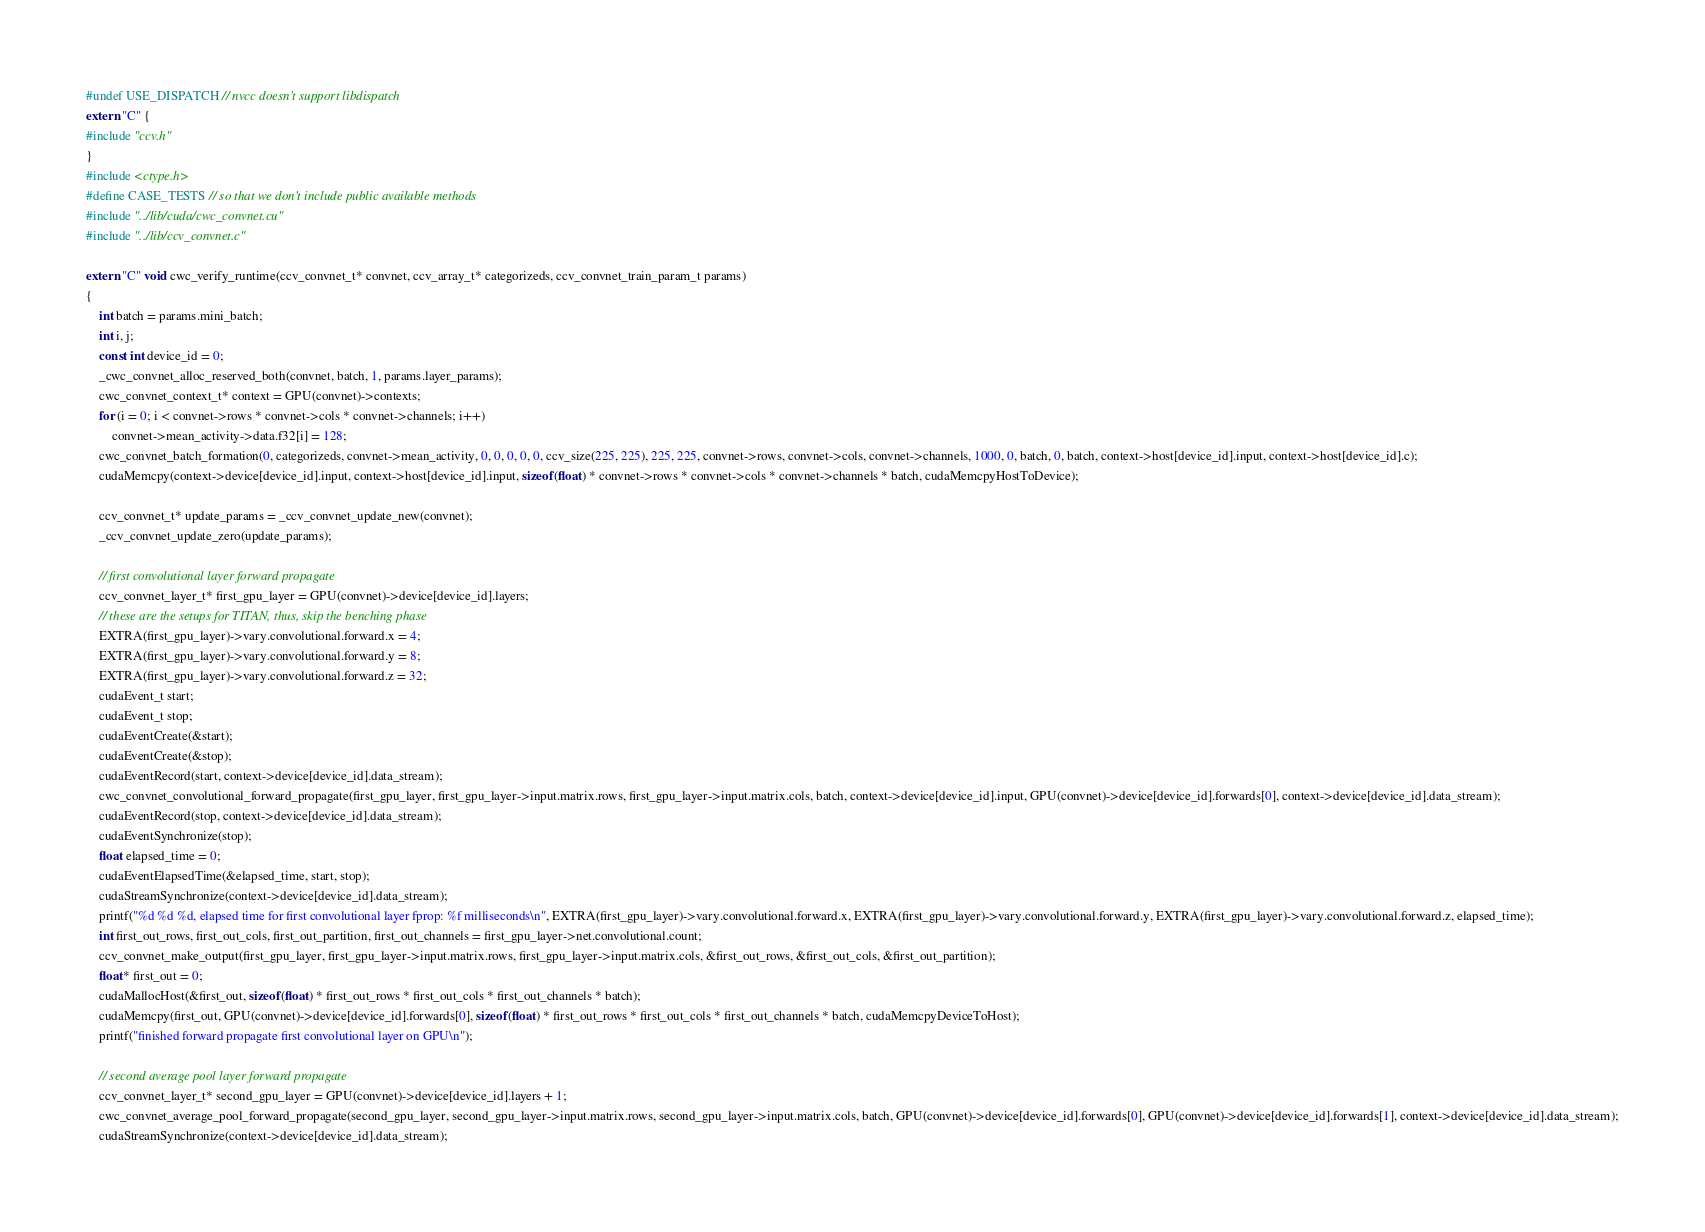<code> <loc_0><loc_0><loc_500><loc_500><_Cuda_>#undef USE_DISPATCH // nvcc doesn't support libdispatch
extern "C" {
#include "ccv.h"
}
#include <ctype.h>
#define CASE_TESTS // so that we don't include public available methods
#include "../lib/cuda/cwc_convnet.cu"
#include "../lib/ccv_convnet.c"

extern "C" void cwc_verify_runtime(ccv_convnet_t* convnet, ccv_array_t* categorizeds, ccv_convnet_train_param_t params)
{
	int batch = params.mini_batch;
	int i, j;
	const int device_id = 0;
	_cwc_convnet_alloc_reserved_both(convnet, batch, 1, params.layer_params);
	cwc_convnet_context_t* context = GPU(convnet)->contexts;
	for (i = 0; i < convnet->rows * convnet->cols * convnet->channels; i++)
		convnet->mean_activity->data.f32[i] = 128;
	cwc_convnet_batch_formation(0, categorizeds, convnet->mean_activity, 0, 0, 0, 0, 0, ccv_size(225, 225), 225, 225, convnet->rows, convnet->cols, convnet->channels, 1000, 0, batch, 0, batch, context->host[device_id].input, context->host[device_id].c);
	cudaMemcpy(context->device[device_id].input, context->host[device_id].input, sizeof(float) * convnet->rows * convnet->cols * convnet->channels * batch, cudaMemcpyHostToDevice);

	ccv_convnet_t* update_params = _ccv_convnet_update_new(convnet);
	_ccv_convnet_update_zero(update_params);

	// first convolutional layer forward propagate
	ccv_convnet_layer_t* first_gpu_layer = GPU(convnet)->device[device_id].layers;
	// these are the setups for TITAN, thus, skip the benching phase
	EXTRA(first_gpu_layer)->vary.convolutional.forward.x = 4;
	EXTRA(first_gpu_layer)->vary.convolutional.forward.y = 8;
	EXTRA(first_gpu_layer)->vary.convolutional.forward.z = 32;
	cudaEvent_t start;
	cudaEvent_t stop;
	cudaEventCreate(&start);
	cudaEventCreate(&stop);
	cudaEventRecord(start, context->device[device_id].data_stream);
	cwc_convnet_convolutional_forward_propagate(first_gpu_layer, first_gpu_layer->input.matrix.rows, first_gpu_layer->input.matrix.cols, batch, context->device[device_id].input, GPU(convnet)->device[device_id].forwards[0], context->device[device_id].data_stream);
	cudaEventRecord(stop, context->device[device_id].data_stream);
	cudaEventSynchronize(stop);
	float elapsed_time = 0;
	cudaEventElapsedTime(&elapsed_time, start, stop);
	cudaStreamSynchronize(context->device[device_id].data_stream);
	printf("%d %d %d, elapsed time for first convolutional layer fprop: %f milliseconds\n", EXTRA(first_gpu_layer)->vary.convolutional.forward.x, EXTRA(first_gpu_layer)->vary.convolutional.forward.y, EXTRA(first_gpu_layer)->vary.convolutional.forward.z, elapsed_time);
	int first_out_rows, first_out_cols, first_out_partition, first_out_channels = first_gpu_layer->net.convolutional.count;
	ccv_convnet_make_output(first_gpu_layer, first_gpu_layer->input.matrix.rows, first_gpu_layer->input.matrix.cols, &first_out_rows, &first_out_cols, &first_out_partition);
	float* first_out = 0;
	cudaMallocHost(&first_out, sizeof(float) * first_out_rows * first_out_cols * first_out_channels * batch);
	cudaMemcpy(first_out, GPU(convnet)->device[device_id].forwards[0], sizeof(float) * first_out_rows * first_out_cols * first_out_channels * batch, cudaMemcpyDeviceToHost);
	printf("finished forward propagate first convolutional layer on GPU\n");

	// second average pool layer forward propagate
	ccv_convnet_layer_t* second_gpu_layer = GPU(convnet)->device[device_id].layers + 1;
	cwc_convnet_average_pool_forward_propagate(second_gpu_layer, second_gpu_layer->input.matrix.rows, second_gpu_layer->input.matrix.cols, batch, GPU(convnet)->device[device_id].forwards[0], GPU(convnet)->device[device_id].forwards[1], context->device[device_id].data_stream);
	cudaStreamSynchronize(context->device[device_id].data_stream);</code> 